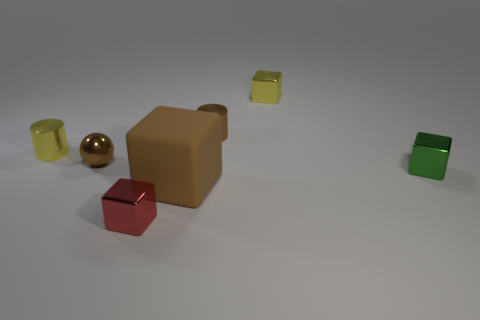What is the material of the small yellow object that is the same shape as the green shiny thing?
Your response must be concise. Metal. There is a green thing that is the same material as the brown cylinder; what is its shape?
Provide a succinct answer. Cube. There is a yellow metal cube; does it have the same size as the shiny cylinder that is to the left of the tiny red shiny cube?
Your response must be concise. Yes. There is a metal object that is both to the right of the brown cylinder and behind the small yellow metal cylinder; how big is it?
Keep it short and to the point. Small. Is there a cylinder of the same color as the matte cube?
Your answer should be very brief. Yes. What is the color of the shiny cylinder that is left of the brown thing behind the small yellow cylinder?
Provide a succinct answer. Yellow. Are there fewer cylinders right of the tiny green metallic cube than big things to the left of the red cube?
Your response must be concise. No. Do the brown metallic ball and the yellow shiny cube have the same size?
Give a very brief answer. Yes. The tiny object that is both left of the tiny yellow metal cube and on the right side of the big brown block has what shape?
Provide a short and direct response. Cylinder. How many other small objects have the same material as the small green object?
Your response must be concise. 5. 